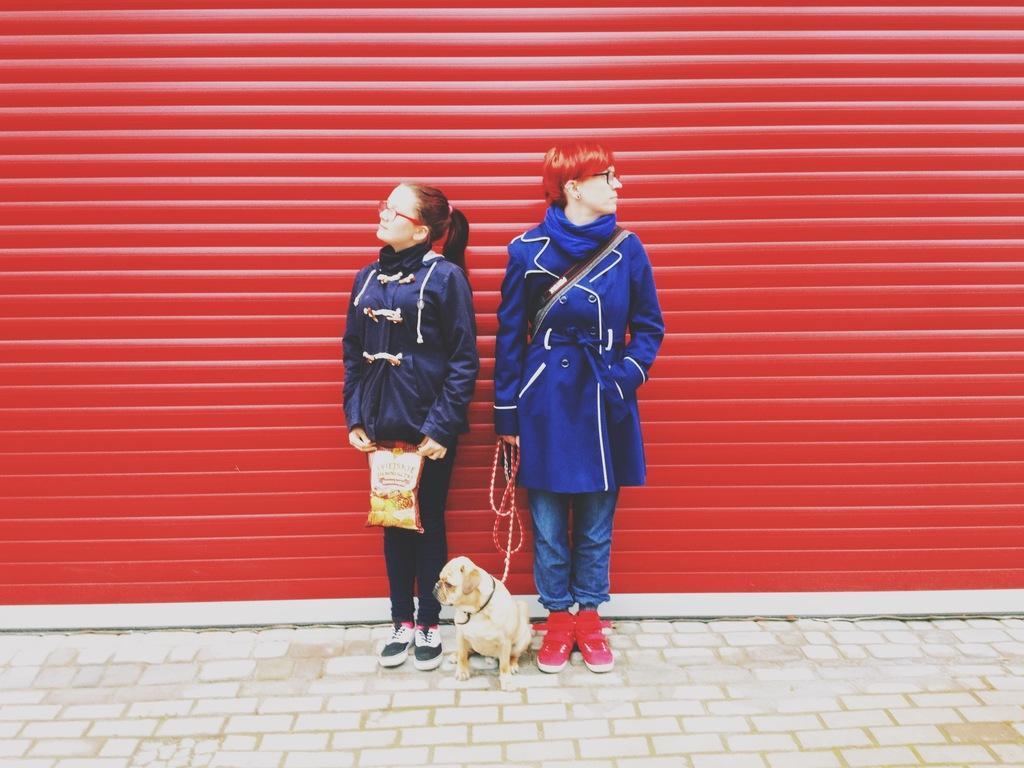Can you describe this image briefly? In this picture we can see 2 people holding a puppy and a packet. They are standing on the ground in front of a red shutter. 